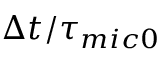<formula> <loc_0><loc_0><loc_500><loc_500>{ \Delta t } / { { { \tau } _ { m i c 0 } } }</formula> 